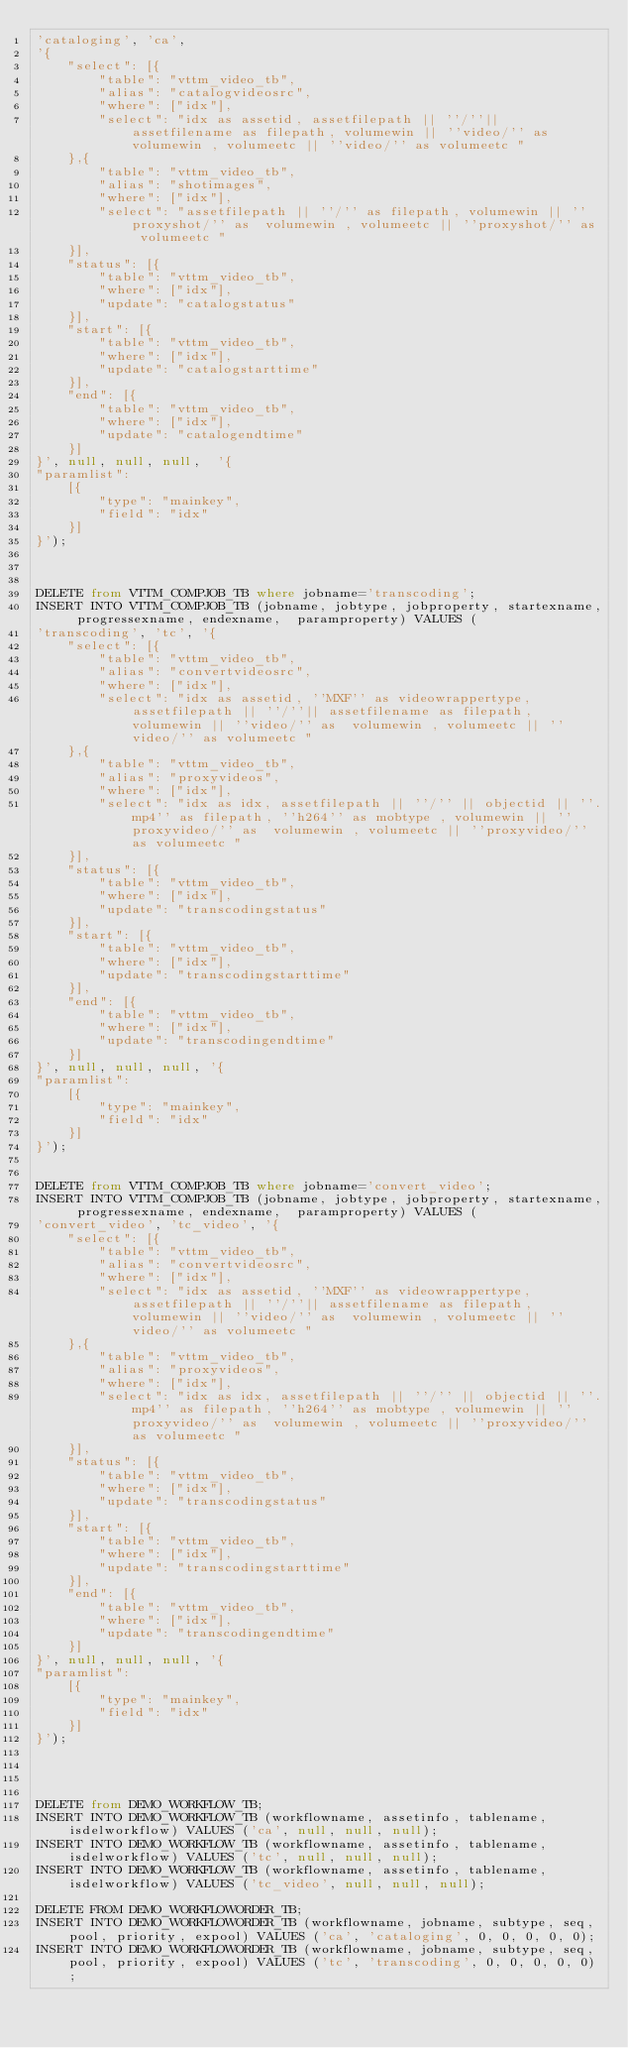<code> <loc_0><loc_0><loc_500><loc_500><_SQL_>'cataloging', 'ca',
'{
	"select": [{
		"table": "vttm_video_tb",
		"alias": "catalogvideosrc",
		"where": ["idx"],
		"select": "idx as assetid, assetfilepath || ''/''|| assetfilename as filepath, volumewin || ''video/'' as  volumewin , volumeetc || ''video/'' as volumeetc "
	},{
		"table": "vttm_video_tb",
		"alias": "shotimages",
		"where": ["idx"],
		"select": "assetfilepath || ''/'' as filepath, volumewin || ''proxyshot/'' as  volumewin , volumeetc || ''proxyshot/'' as volumeetc "
	}],
	"status": [{
		"table": "vttm_video_tb",
		"where": ["idx"],
		"update": "catalogstatus"
	}],
	"start": [{
		"table": "vttm_video_tb",
		"where": ["idx"],
		"update": "catalogstarttime"
	}],
	"end": [{
		"table": "vttm_video_tb",
		"where": ["idx"],
		"update": "catalogendtime"
	}]
}', null, null, null,  '{
"paramlist":
	[{
		"type": "mainkey",
		"field": "idx"
	}]
}');



DELETE from VTTM_COMPJOB_TB where jobname='transcoding';
INSERT INTO VTTM_COMPJOB_TB (jobname, jobtype, jobproperty, startexname, progressexname, endexname,  paramproperty) VALUES (
'transcoding', 'tc', '{
	"select": [{
		"table": "vttm_video_tb",
		"alias": "convertvideosrc",
		"where": ["idx"],
		"select": "idx as assetid, ''MXF'' as videowrappertype, assetfilepath || ''/''|| assetfilename as filepath, volumewin || ''video/'' as  volumewin , volumeetc || ''video/'' as volumeetc "
	},{
		"table": "vttm_video_tb",
		"alias": "proxyvideos",
		"where": ["idx"],
		"select": "idx as idx, assetfilepath || ''/'' || objectid || ''.mp4'' as filepath, ''h264'' as mobtype , volumewin || ''proxyvideo/'' as  volumewin , volumeetc || ''proxyvideo/'' as volumeetc "
	}],
	"status": [{
		"table": "vttm_video_tb",
		"where": ["idx"],
		"update": "transcodingstatus"
	}],
	"start": [{
		"table": "vttm_video_tb",
		"where": ["idx"],
		"update": "transcodingstarttime"
	}],
	"end": [{
		"table": "vttm_video_tb",
		"where": ["idx"],
		"update": "transcodingendtime"
	}]
}', null, null, null, '{
"paramlist":
	[{
		"type": "mainkey",
		"field": "idx"
	}]
}');


DELETE from VTTM_COMPJOB_TB where jobname='convert_video';
INSERT INTO VTTM_COMPJOB_TB (jobname, jobtype, jobproperty, startexname, progressexname, endexname,  paramproperty) VALUES (
'convert_video', 'tc_video', '{
	"select": [{
		"table": "vttm_video_tb",
		"alias": "convertvideosrc",
		"where": ["idx"],
		"select": "idx as assetid, ''MXF'' as videowrappertype, assetfilepath || ''/''|| assetfilename as filepath, volumewin || ''video/'' as  volumewin , volumeetc || ''video/'' as volumeetc "
	},{
		"table": "vttm_video_tb",
		"alias": "proxyvideos",
		"where": ["idx"],
		"select": "idx as idx, assetfilepath || ''/'' || objectid || ''.mp4'' as filepath, ''h264'' as mobtype , volumewin || ''proxyvideo/'' as  volumewin , volumeetc || ''proxyvideo/'' as volumeetc "
	}],
	"status": [{
		"table": "vttm_video_tb",
		"where": ["idx"],
		"update": "transcodingstatus"
	}],
	"start": [{
		"table": "vttm_video_tb",
		"where": ["idx"],
		"update": "transcodingstarttime"
	}],
	"end": [{
		"table": "vttm_video_tb",
		"where": ["idx"],
		"update": "transcodingendtime"
	}]
}', null, null, null, '{
"paramlist":
	[{
		"type": "mainkey",
		"field": "idx"
	}]
}');




DELETE from DEMO_WORKFLOW_TB;
INSERT INTO DEMO_WORKFLOW_TB (workflowname, assetinfo, tablename, isdelworkflow) VALUES ('ca', null, null, null);
INSERT INTO DEMO_WORKFLOW_TB (workflowname, assetinfo, tablename, isdelworkflow) VALUES ('tc', null, null, null);
INSERT INTO DEMO_WORKFLOW_TB (workflowname, assetinfo, tablename, isdelworkflow) VALUES ('tc_video', null, null, null);

DELETE FROM DEMO_WORKFLOWORDER_TB;
INSERT INTO DEMO_WORKFLOWORDER_TB (workflowname, jobname, subtype, seq, pool, priority, expool) VALUES ('ca', 'cataloging', 0, 0, 0, 0, 0);
INSERT INTO DEMO_WORKFLOWORDER_TB (workflowname, jobname, subtype, seq, pool, priority, expool) VALUES ('tc', 'transcoding', 0, 0, 0, 0, 0);</code> 